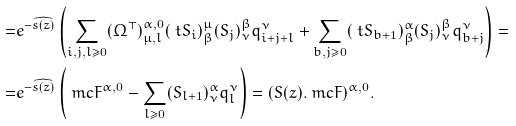<formula> <loc_0><loc_0><loc_500><loc_500>= & e ^ { - \widehat { s ( z ) } } \left ( \sum _ { i , j , l \geq 0 } ( \Omega ^ { \top } ) ^ { \alpha , 0 } _ { \mu , l } ( \ t S _ { i } ) ^ { \mu } _ { \beta } ( S _ { j } ) ^ { \beta } _ { \nu } q ^ { \nu } _ { i + j + l } + \sum _ { b , j \geq 0 } ( \ t S _ { b + 1 } ) ^ { \alpha } _ { \beta } ( S _ { j } ) ^ { \beta } _ { \nu } q ^ { \nu } _ { b + j } \right ) = \\ = & e ^ { - \widehat { s ( z ) } } \left ( \ m c F ^ { \alpha , 0 } - \sum _ { l \geq 0 } ( S _ { l + 1 } ) ^ { \alpha } _ { \nu } q ^ { \nu } _ { l } \right ) = ( S ( z ) . \ m c F ) ^ { \alpha , 0 } .</formula> 